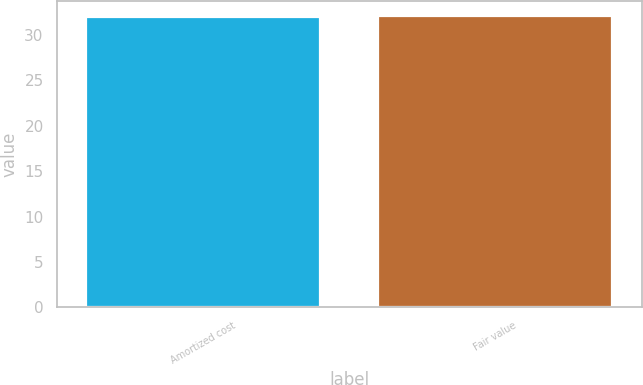Convert chart. <chart><loc_0><loc_0><loc_500><loc_500><bar_chart><fcel>Amortized cost<fcel>Fair value<nl><fcel>32<fcel>32.1<nl></chart> 